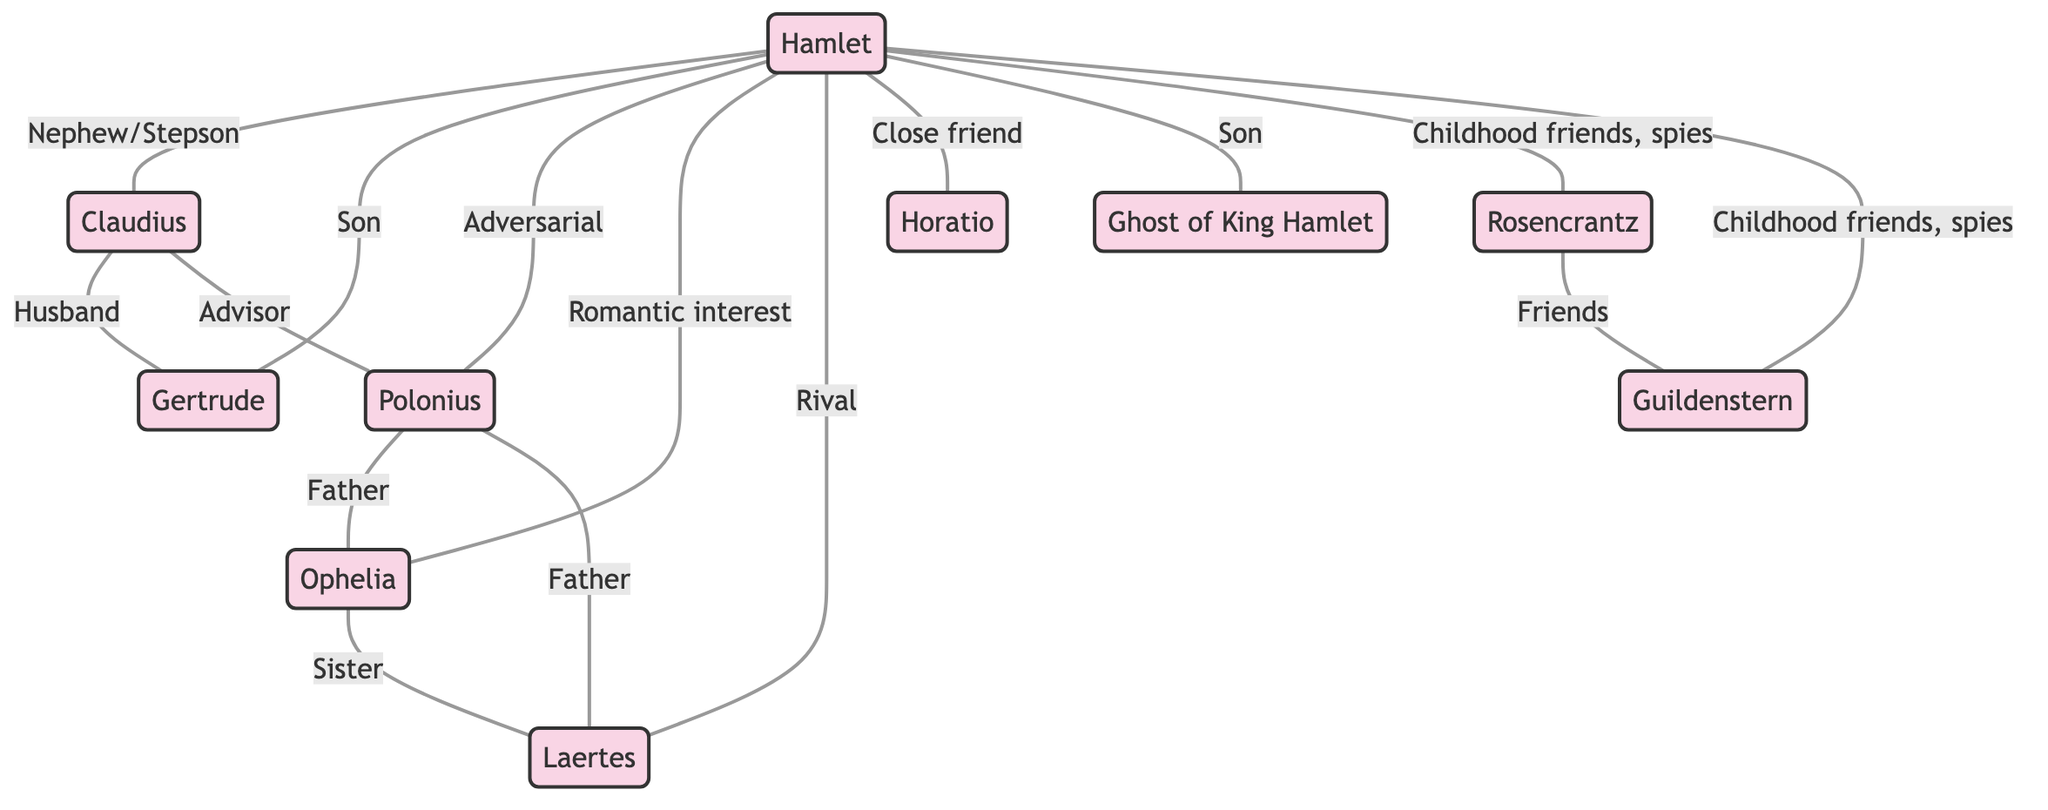What is the total number of characters in the graph? The characters listed in the data are Hamlet, Claudius, Gertrude, Polonius, Ophelia, Laertes, Horatio, Ghost of King Hamlet, Rosencrantz, and Guildenstern. Counting these gives us a total of 10 characters.
Answer: 10 What is the relationship between Hamlet and Gertrude? In the diagram, the connection shows that Hamlet is the son to Gertrude, which is explicitly stated as "Son to Mother".
Answer: Son to Mother How many connections does Claudius have? By examining the connections, Claudius is linked to Gertrude and Polonius. This gives him a total of 2 connections.
Answer: 2 What type of relationship does Hamlet have with Ophelia? The diagram indicates a romantic interest between Hamlet and Ophelia. This is summarised in the connection as "Romantic interest".
Answer: Romantic interest Who is the father of Laertes? The graph shows that Polonius has a connection to Laertes, indicating that Polonius is the father to Laertes, as specified in the relationship "Father to Son".
Answer: Polonius Which characters have a friendship connection? The connection between Rosencrantz and Guildenstern states they are friends, described with "Friends". There are no other friendship connections mentioned in the diagram.
Answer: Rosencrantz and Guildenstern What is the relationship type between Hamlet and Horatio? The diagram identifies the relationship between Hamlet and Horatio as "Close friend", which is specified in the connection.
Answer: Close friend How many rivalries are depicted in the graph? The graph shows that Hamlet has a rivalry with Laertes, as indicated by the connection "Rival". Since this is the only rivalry listed, the count is 1.
Answer: 1 In what way is the Ghost of King Hamlet related to Hamlet? The connection specifies that Hamlet has a relationship of "Son to Father" with the Ghost of King Hamlet, clarifying their relationship in the context of Hamlet's quest.
Answer: Son to Father 